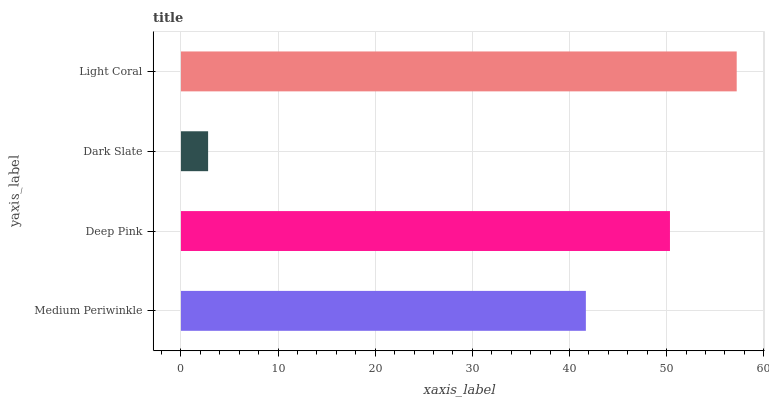Is Dark Slate the minimum?
Answer yes or no. Yes. Is Light Coral the maximum?
Answer yes or no. Yes. Is Deep Pink the minimum?
Answer yes or no. No. Is Deep Pink the maximum?
Answer yes or no. No. Is Deep Pink greater than Medium Periwinkle?
Answer yes or no. Yes. Is Medium Periwinkle less than Deep Pink?
Answer yes or no. Yes. Is Medium Periwinkle greater than Deep Pink?
Answer yes or no. No. Is Deep Pink less than Medium Periwinkle?
Answer yes or no. No. Is Deep Pink the high median?
Answer yes or no. Yes. Is Medium Periwinkle the low median?
Answer yes or no. Yes. Is Medium Periwinkle the high median?
Answer yes or no. No. Is Dark Slate the low median?
Answer yes or no. No. 